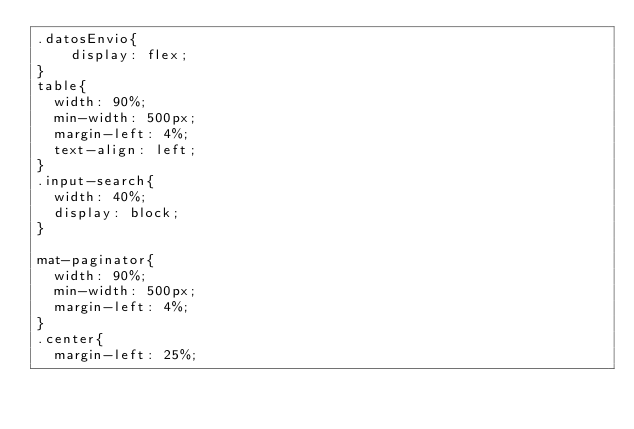<code> <loc_0><loc_0><loc_500><loc_500><_CSS_>.datosEnvio{
    display: flex;
}
table{
  width: 90%;
  min-width: 500px;
  margin-left: 4%;
  text-align: left;
}
.input-search{
  width: 40%;
  display: block;
}

mat-paginator{
  width: 90%;
  min-width: 500px;
  margin-left: 4%;
}
.center{
  margin-left: 25%;</code> 